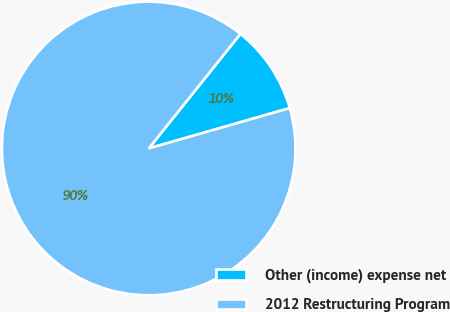Convert chart. <chart><loc_0><loc_0><loc_500><loc_500><pie_chart><fcel>Other (income) expense net<fcel>2012 Restructuring Program<nl><fcel>9.82%<fcel>90.18%<nl></chart> 